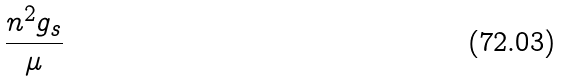Convert formula to latex. <formula><loc_0><loc_0><loc_500><loc_500>\frac { n ^ { 2 } g _ { s } } { \mu }</formula> 